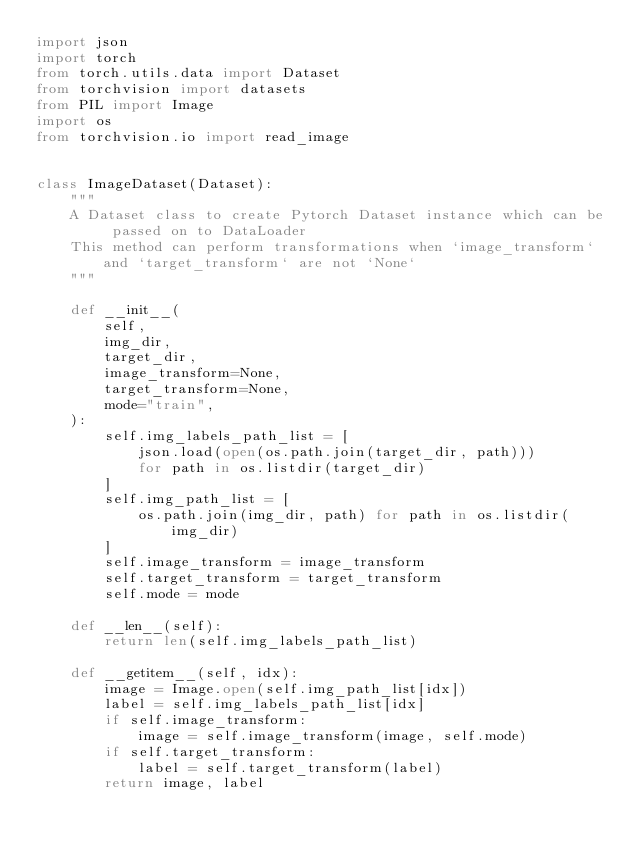Convert code to text. <code><loc_0><loc_0><loc_500><loc_500><_Python_>import json
import torch
from torch.utils.data import Dataset
from torchvision import datasets
from PIL import Image
import os
from torchvision.io import read_image


class ImageDataset(Dataset):
    """
    A Dataset class to create Pytorch Dataset instance which can be passed on to DataLoader
    This method can perform transformations when `image_transform` and `target_transform` are not `None`
    """

    def __init__(
        self,
        img_dir,
        target_dir,
        image_transform=None,
        target_transform=None,
        mode="train",
    ):
        self.img_labels_path_list = [
            json.load(open(os.path.join(target_dir, path)))
            for path in os.listdir(target_dir)
        ]
        self.img_path_list = [
            os.path.join(img_dir, path) for path in os.listdir(img_dir)
        ]
        self.image_transform = image_transform
        self.target_transform = target_transform
        self.mode = mode

    def __len__(self):
        return len(self.img_labels_path_list)

    def __getitem__(self, idx):
        image = Image.open(self.img_path_list[idx])
        label = self.img_labels_path_list[idx]
        if self.image_transform:
            image = self.image_transform(image, self.mode)
        if self.target_transform:
            label = self.target_transform(label)
        return image, label
</code> 